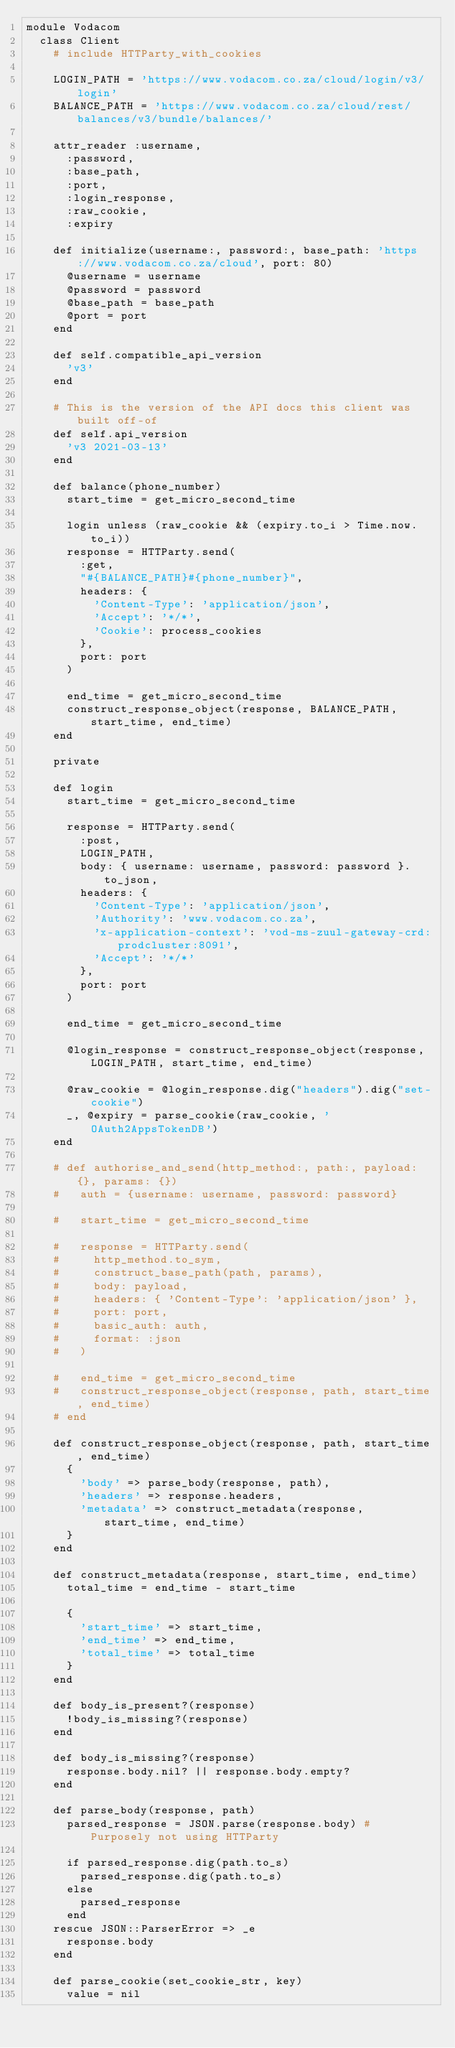<code> <loc_0><loc_0><loc_500><loc_500><_Ruby_>module Vodacom
  class Client
    # include HTTParty_with_cookies

    LOGIN_PATH = 'https://www.vodacom.co.za/cloud/login/v3/login'
    BALANCE_PATH = 'https://www.vodacom.co.za/cloud/rest/balances/v3/bundle/balances/'

    attr_reader :username,
      :password,
      :base_path,
      :port,
      :login_response,
      :raw_cookie,
      :expiry

    def initialize(username:, password:, base_path: 'https://www.vodacom.co.za/cloud', port: 80)
      @username = username
      @password = password
      @base_path = base_path
      @port = port
    end

    def self.compatible_api_version
      'v3'
    end

    # This is the version of the API docs this client was built off-of
    def self.api_version
      'v3 2021-03-13'
    end

    def balance(phone_number)
      start_time = get_micro_second_time

      login unless (raw_cookie && (expiry.to_i > Time.now.to_i))
      response = HTTParty.send(
        :get,
        "#{BALANCE_PATH}#{phone_number}",
        headers: {
          'Content-Type': 'application/json',
          'Accept': '*/*',
          'Cookie': process_cookies
        },
        port: port
      )

      end_time = get_micro_second_time
      construct_response_object(response, BALANCE_PATH, start_time, end_time)
    end

    private

    def login
      start_time = get_micro_second_time

      response = HTTParty.send(
        :post,
        LOGIN_PATH,
        body: { username: username, password: password }.to_json,
        headers: {
          'Content-Type': 'application/json',
          'Authority': 'www.vodacom.co.za',
          'x-application-context': 'vod-ms-zuul-gateway-crd:prodcluster:8091',
          'Accept': '*/*'
        },
        port: port
      )

      end_time = get_micro_second_time

      @login_response = construct_response_object(response, LOGIN_PATH, start_time, end_time)

      @raw_cookie = @login_response.dig("headers").dig("set-cookie")
      _, @expiry = parse_cookie(raw_cookie, 'OAuth2AppsTokenDB')
    end

    # def authorise_and_send(http_method:, path:, payload: {}, params: {})
    #   auth = {username: username, password: password}

    #   start_time = get_micro_second_time

    #   response = HTTParty.send(
    #     http_method.to_sym,
    #     construct_base_path(path, params),
    #     body: payload,
    #     headers: { 'Content-Type': 'application/json' },
    #     port: port,
    #     basic_auth: auth,
    #     format: :json
    #   )

    #   end_time = get_micro_second_time
    #   construct_response_object(response, path, start_time, end_time)
    # end

    def construct_response_object(response, path, start_time, end_time)
      {
        'body' => parse_body(response, path),
        'headers' => response.headers,
        'metadata' => construct_metadata(response, start_time, end_time)
      }
    end

    def construct_metadata(response, start_time, end_time)
      total_time = end_time - start_time

      {
        'start_time' => start_time,
        'end_time' => end_time,
        'total_time' => total_time
      }
    end

    def body_is_present?(response)
      !body_is_missing?(response)
    end

    def body_is_missing?(response)
      response.body.nil? || response.body.empty?
    end

    def parse_body(response, path)
      parsed_response = JSON.parse(response.body) # Purposely not using HTTParty

      if parsed_response.dig(path.to_s)
        parsed_response.dig(path.to_s)
      else
        parsed_response
      end
    rescue JSON::ParserError => _e
      response.body
    end

    def parse_cookie(set_cookie_str, key)
      value = nil</code> 